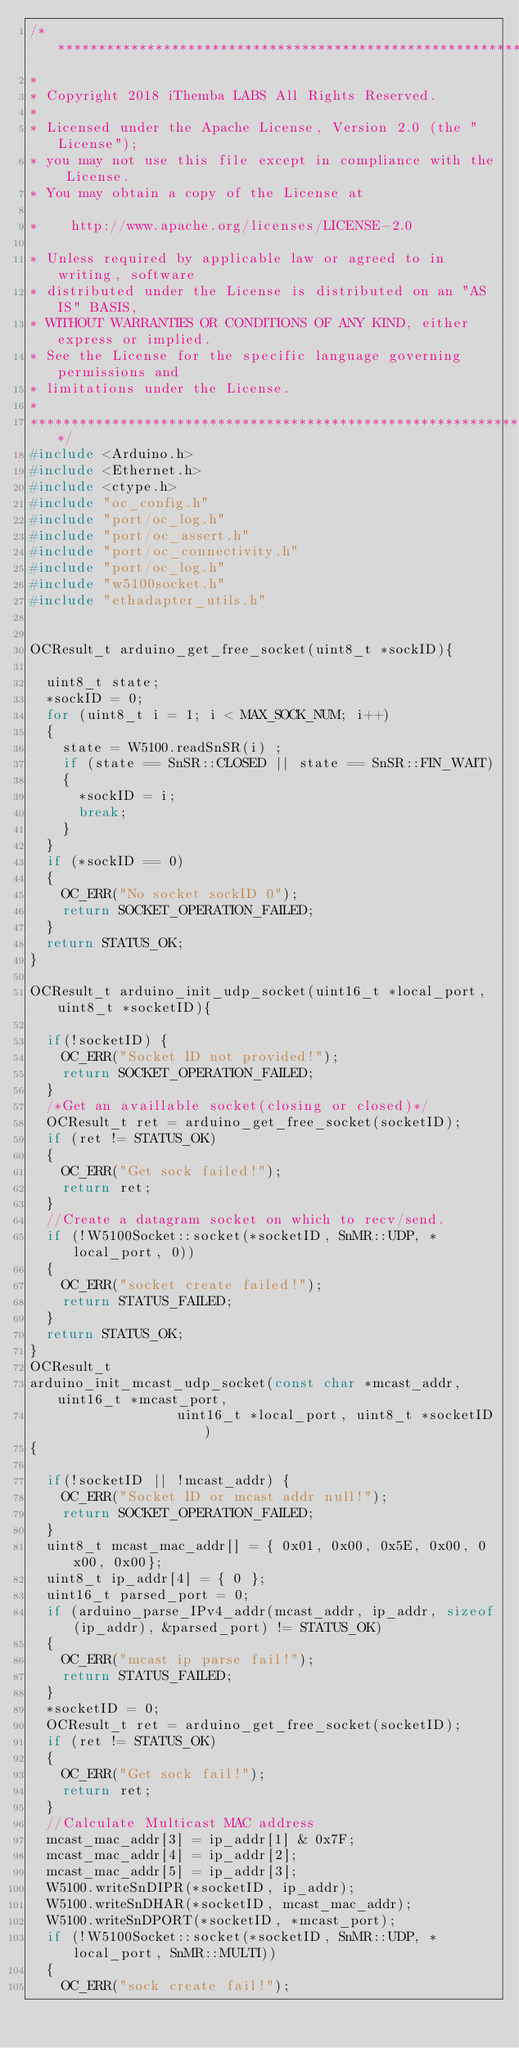<code> <loc_0><loc_0><loc_500><loc_500><_C++_>/******************************************************************
*
* Copyright 2018 iThemba LABS All Rights Reserved.
*
* Licensed under the Apache License, Version 2.0 (the "License");
* you may not use this file except in compliance with the License.
* You may obtain a copy of the License at

*    http://www.apache.org/licenses/LICENSE-2.0

* Unless required by applicable law or agreed to in writing, software
* distributed under the License is distributed on an "AS IS" BASIS,
* WITHOUT WARRANTIES OR CONDITIONS OF ANY KIND, either express or implied.
* See the License for the specific language governing permissions and
* limitations under the License.
*
******************************************************************/
#include <Arduino.h>
#include <Ethernet.h>
#include <ctype.h>
#include "oc_config.h"
#include "port/oc_log.h"
#include "port/oc_assert.h"
#include "port/oc_connectivity.h"
#include "port/oc_log.h"
#include "w5100socket.h"
#include "ethadapter_utils.h"


OCResult_t arduino_get_free_socket(uint8_t *sockID){

	uint8_t state;
	*sockID = 0;
	for (uint8_t i = 1; i < MAX_SOCK_NUM; i++)
	{
		state = W5100.readSnSR(i) ;
		if (state == SnSR::CLOSED || state == SnSR::FIN_WAIT)
		{
			*sockID = i;
			break;
		}
	}
	if (*sockID == 0)
	{
		OC_ERR("No socket sockID 0");
		return SOCKET_OPERATION_FAILED;
	}
	return STATUS_OK;
}

OCResult_t arduino_init_udp_socket(uint16_t *local_port, uint8_t *socketID){

	if(!socketID) {
		OC_ERR("Socket ID not provided!");
		return SOCKET_OPERATION_FAILED;
	}
	/*Get an availlable socket(closing or closed)*/
	OCResult_t ret = arduino_get_free_socket(socketID);
	if (ret != STATUS_OK)
	{
		OC_ERR("Get sock failed!");
		return ret;
	}
	//Create a datagram socket on which to recv/send.
	if (!W5100Socket::socket(*socketID, SnMR::UDP, *local_port, 0))
	{
		OC_ERR("socket create failed!");
		return STATUS_FAILED;
	}
	return STATUS_OK;
}
OCResult_t
arduino_init_mcast_udp_socket(const char *mcast_addr, uint16_t *mcast_port,
									uint16_t *local_port, uint8_t *socketID)
{

	if(!socketID || !mcast_addr) {
		OC_ERR("Socket ID or mcast addr null!");
		return SOCKET_OPERATION_FAILED;
	}
	uint8_t mcast_mac_addr[] = { 0x01, 0x00, 0x5E, 0x00, 0x00, 0x00};
	uint8_t ip_addr[4] = { 0 };
	uint16_t parsed_port = 0;
	if (arduino_parse_IPv4_addr(mcast_addr, ip_addr, sizeof(ip_addr), &parsed_port) != STATUS_OK)
	{
		OC_ERR("mcast ip parse fail!");
		return STATUS_FAILED;
	}
	*socketID = 0;
	OCResult_t ret = arduino_get_free_socket(socketID);
	if (ret != STATUS_OK)
	{
		OC_ERR("Get sock fail!");
		return ret;
	}
	//Calculate Multicast MAC address
	mcast_mac_addr[3] = ip_addr[1] & 0x7F;
	mcast_mac_addr[4] = ip_addr[2];
	mcast_mac_addr[5] = ip_addr[3];
	W5100.writeSnDIPR(*socketID, ip_addr);
	W5100.writeSnDHAR(*socketID, mcast_mac_addr);
	W5100.writeSnDPORT(*socketID, *mcast_port);
	if (!W5100Socket::socket(*socketID, SnMR::UDP, *local_port, SnMR::MULTI))
	{
		OC_ERR("sock create fail!");</code> 